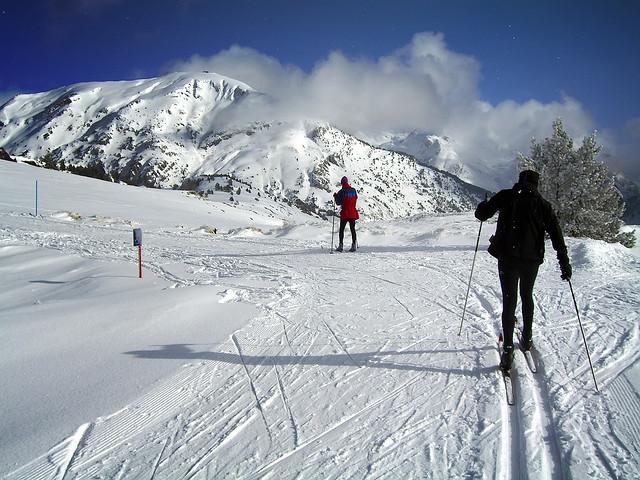Does the snow look the same across the entire picture?
Keep it brief. No. What color does the person in the back have on?
Answer briefly. Black. Are both skiers skiing in another person's tracks?
Be succinct. Yes. What type of sport are these persons engaging in?
Concise answer only. Skiing. 